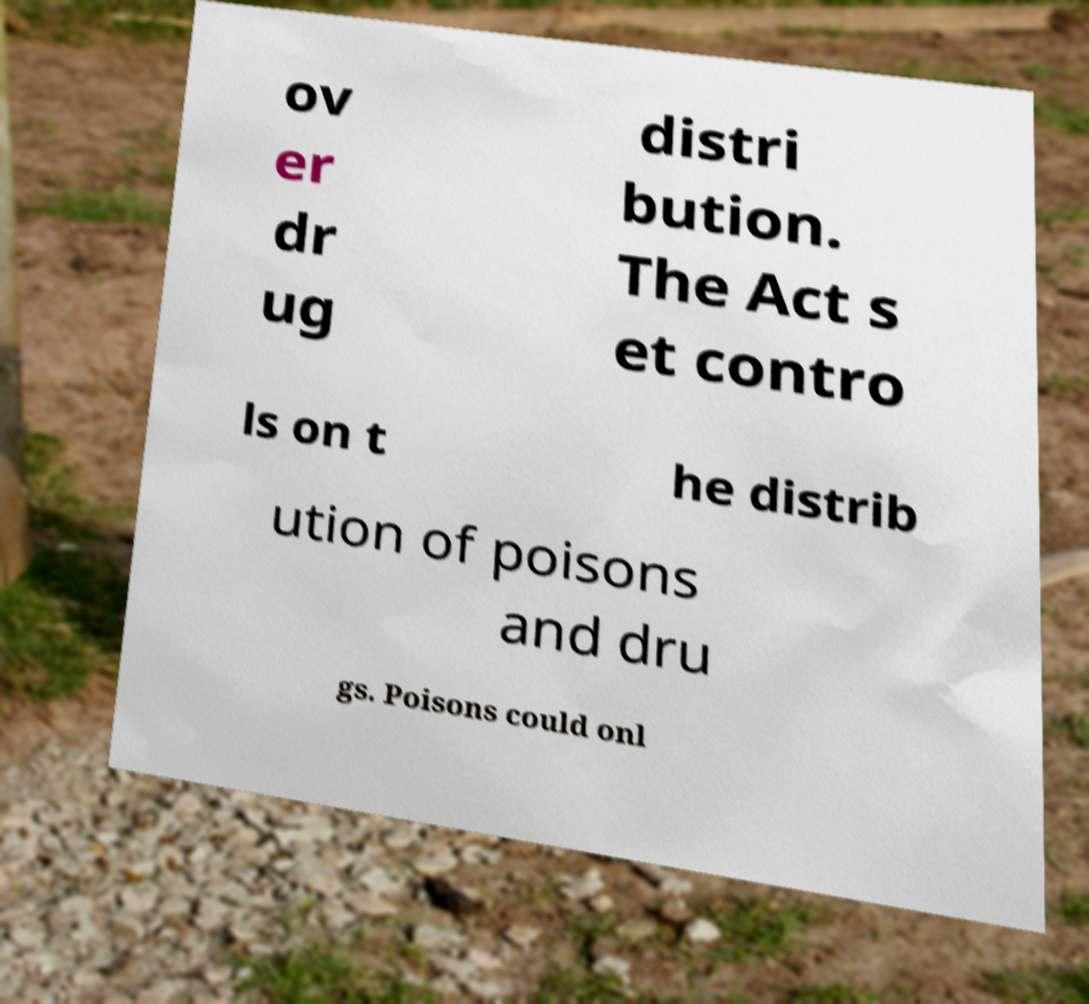Could you extract and type out the text from this image? ov er dr ug distri bution. The Act s et contro ls on t he distrib ution of poisons and dru gs. Poisons could onl 